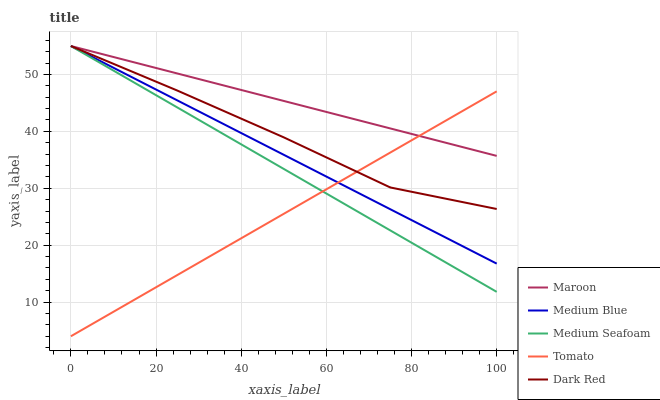Does Tomato have the minimum area under the curve?
Answer yes or no. Yes. Does Maroon have the maximum area under the curve?
Answer yes or no. Yes. Does Dark Red have the minimum area under the curve?
Answer yes or no. No. Does Dark Red have the maximum area under the curve?
Answer yes or no. No. Is Tomato the smoothest?
Answer yes or no. Yes. Is Dark Red the roughest?
Answer yes or no. Yes. Is Medium Blue the smoothest?
Answer yes or no. No. Is Medium Blue the roughest?
Answer yes or no. No. Does Tomato have the lowest value?
Answer yes or no. Yes. Does Dark Red have the lowest value?
Answer yes or no. No. Does Maroon have the highest value?
Answer yes or no. Yes. Does Medium Seafoam intersect Maroon?
Answer yes or no. Yes. Is Medium Seafoam less than Maroon?
Answer yes or no. No. Is Medium Seafoam greater than Maroon?
Answer yes or no. No. 